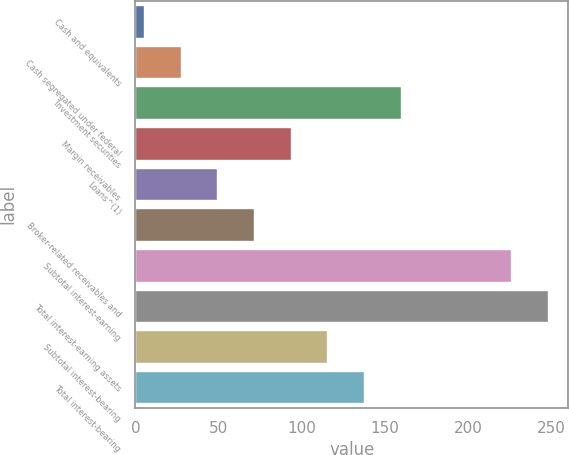Convert chart to OTSL. <chart><loc_0><loc_0><loc_500><loc_500><bar_chart><fcel>Cash and equivalents<fcel>Cash segregated under federal<fcel>Investment securities<fcel>Margin receivables<fcel>Loans^(1)<fcel>Broker-related receivables and<fcel>Subtotal interest-earning<fcel>Total interest-earning assets<fcel>Subtotal interest-bearing<fcel>Total interest-bearing<nl><fcel>5<fcel>27.1<fcel>159.7<fcel>93.4<fcel>49.2<fcel>71.3<fcel>226<fcel>248.1<fcel>115.5<fcel>137.6<nl></chart> 